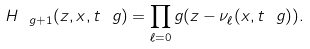Convert formula to latex. <formula><loc_0><loc_0><loc_500><loc_500>H _ { \ g + 1 } ( z , x , t _ { \ } g ) = \prod _ { \ell = 0 } ^ { \ } g ( z - \nu _ { \ell } ( x , t _ { \ } g ) ) .</formula> 